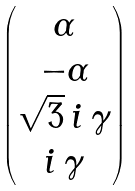<formula> <loc_0><loc_0><loc_500><loc_500>\begin{pmatrix} \alpha \\ - \alpha \\ \sqrt { 3 } \, i \, \gamma \\ i \, \gamma \end{pmatrix}</formula> 